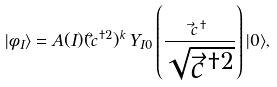<formula> <loc_0><loc_0><loc_500><loc_500>| \phi _ { I } \rangle = A ( I ) ( \vec { c } ^ { \, \dagger 2 } ) ^ { k } \, Y _ { I 0 } \left ( \frac { \vec { c } ^ { \, \dagger } } { \sqrt { \vec { c } ^ { \, \dagger 2 } } } \right ) | 0 \rangle ,</formula> 